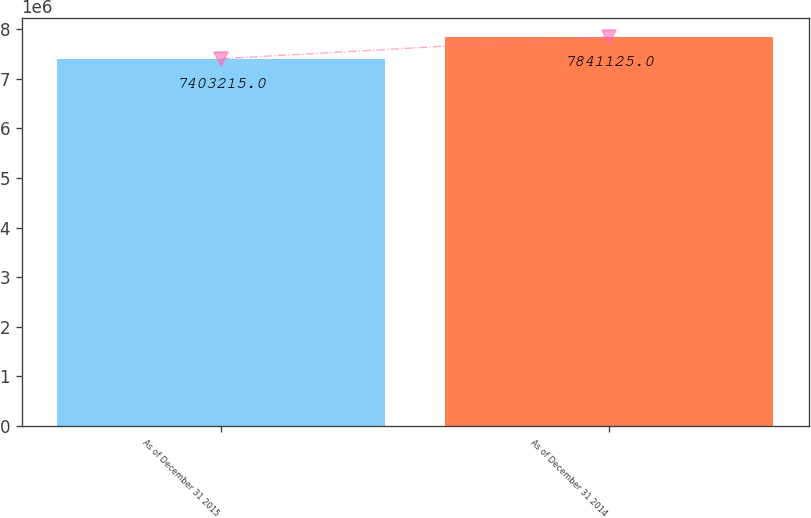Convert chart to OTSL. <chart><loc_0><loc_0><loc_500><loc_500><bar_chart><fcel>As of December 31 2015<fcel>As of December 31 2014<nl><fcel>7.40322e+06<fcel>7.84112e+06<nl></chart> 